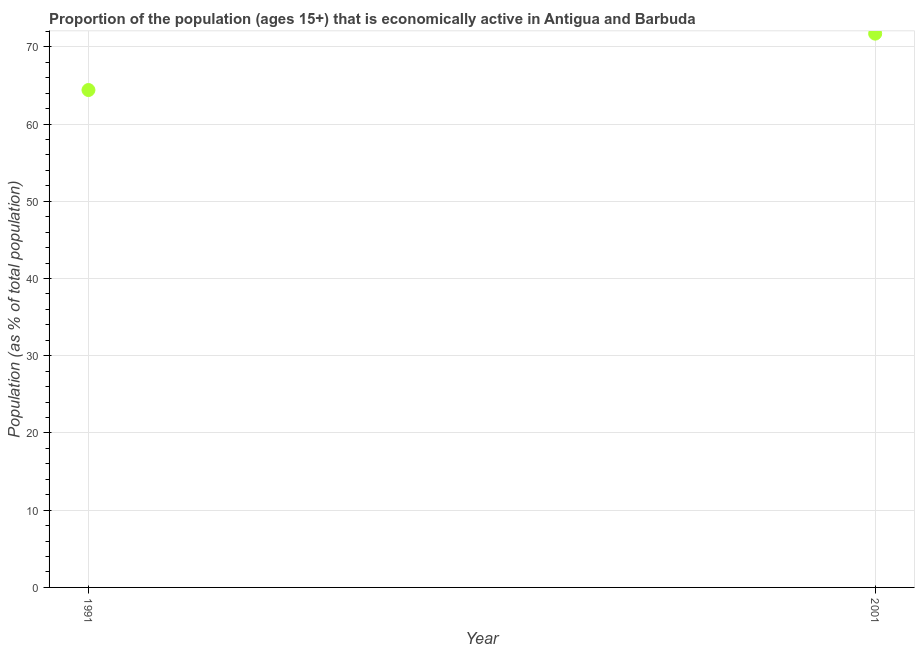What is the percentage of economically active population in 1991?
Your response must be concise. 64.4. Across all years, what is the maximum percentage of economically active population?
Ensure brevity in your answer.  71.7. Across all years, what is the minimum percentage of economically active population?
Provide a short and direct response. 64.4. In which year was the percentage of economically active population maximum?
Make the answer very short. 2001. What is the sum of the percentage of economically active population?
Offer a terse response. 136.1. What is the difference between the percentage of economically active population in 1991 and 2001?
Your answer should be compact. -7.3. What is the average percentage of economically active population per year?
Offer a very short reply. 68.05. What is the median percentage of economically active population?
Give a very brief answer. 68.05. What is the ratio of the percentage of economically active population in 1991 to that in 2001?
Give a very brief answer. 0.9. Is the percentage of economically active population in 1991 less than that in 2001?
Provide a short and direct response. Yes. In how many years, is the percentage of economically active population greater than the average percentage of economically active population taken over all years?
Your response must be concise. 1. How many dotlines are there?
Your answer should be compact. 1. How many years are there in the graph?
Keep it short and to the point. 2. Are the values on the major ticks of Y-axis written in scientific E-notation?
Offer a terse response. No. Does the graph contain any zero values?
Ensure brevity in your answer.  No. What is the title of the graph?
Offer a terse response. Proportion of the population (ages 15+) that is economically active in Antigua and Barbuda. What is the label or title of the X-axis?
Keep it short and to the point. Year. What is the label or title of the Y-axis?
Give a very brief answer. Population (as % of total population). What is the Population (as % of total population) in 1991?
Your response must be concise. 64.4. What is the Population (as % of total population) in 2001?
Offer a terse response. 71.7. What is the difference between the Population (as % of total population) in 1991 and 2001?
Give a very brief answer. -7.3. What is the ratio of the Population (as % of total population) in 1991 to that in 2001?
Your answer should be compact. 0.9. 